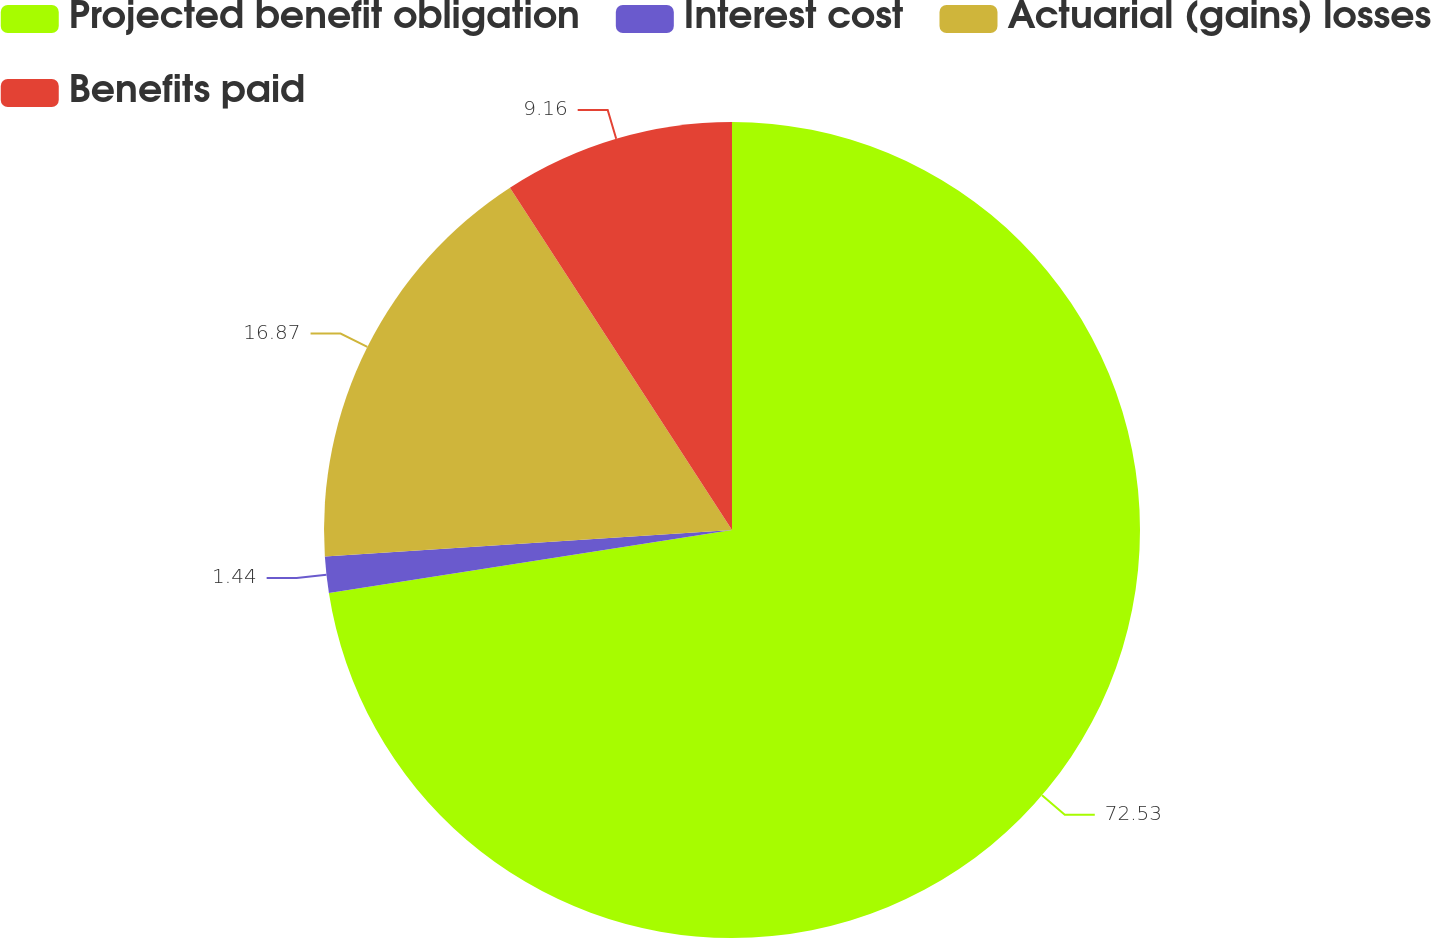Convert chart. <chart><loc_0><loc_0><loc_500><loc_500><pie_chart><fcel>Projected benefit obligation<fcel>Interest cost<fcel>Actuarial (gains) losses<fcel>Benefits paid<nl><fcel>72.53%<fcel>1.44%<fcel>16.87%<fcel>9.16%<nl></chart> 